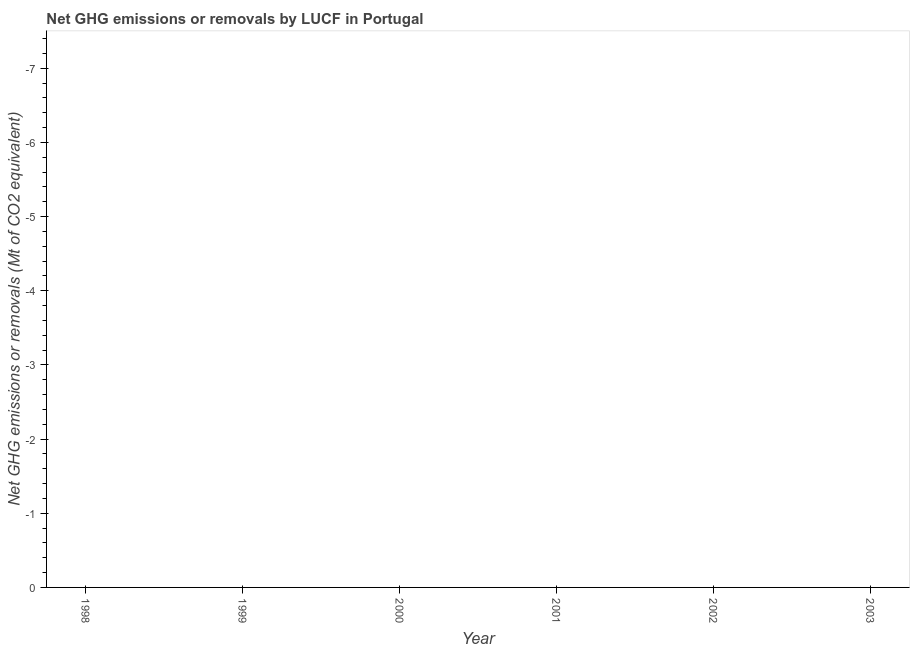Across all years, what is the minimum ghg net emissions or removals?
Give a very brief answer. 0. What is the average ghg net emissions or removals per year?
Your answer should be very brief. 0. What is the median ghg net emissions or removals?
Your answer should be very brief. 0. In how many years, is the ghg net emissions or removals greater than -7 Mt?
Provide a short and direct response. 0. In how many years, is the ghg net emissions or removals greater than the average ghg net emissions or removals taken over all years?
Give a very brief answer. 0. Does the ghg net emissions or removals monotonically increase over the years?
Your answer should be very brief. No. How many lines are there?
Give a very brief answer. 0. Are the values on the major ticks of Y-axis written in scientific E-notation?
Your answer should be very brief. No. Does the graph contain any zero values?
Your answer should be very brief. Yes. What is the title of the graph?
Your answer should be very brief. Net GHG emissions or removals by LUCF in Portugal. What is the label or title of the Y-axis?
Your response must be concise. Net GHG emissions or removals (Mt of CO2 equivalent). What is the Net GHG emissions or removals (Mt of CO2 equivalent) of 2001?
Your response must be concise. 0. 